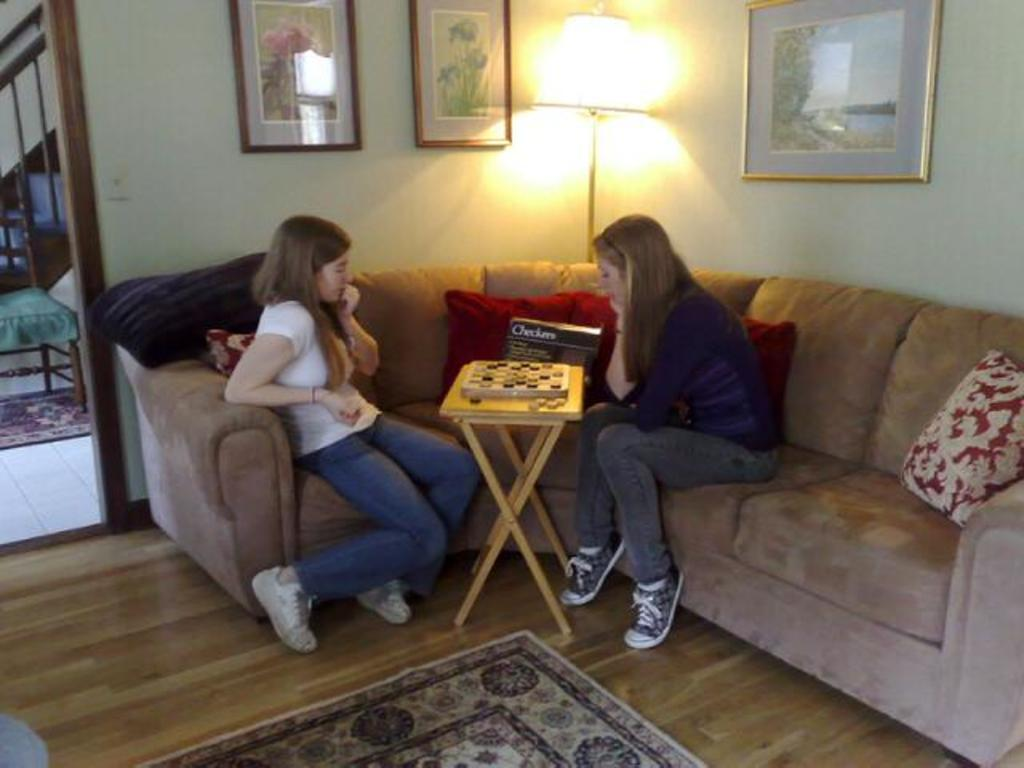How many people are in the image? There are two women in the image. What are the women doing in the image? The women are sitting on a sofa. What can be seen on the wall in the image? There are frames on the wall. What type of lighting is present in the image? There is a lamp in the image. What type of engine can be seen in the image? There is no engine present in the image. Are there any ghosts visible in the image? There are no ghosts visible in the image. 